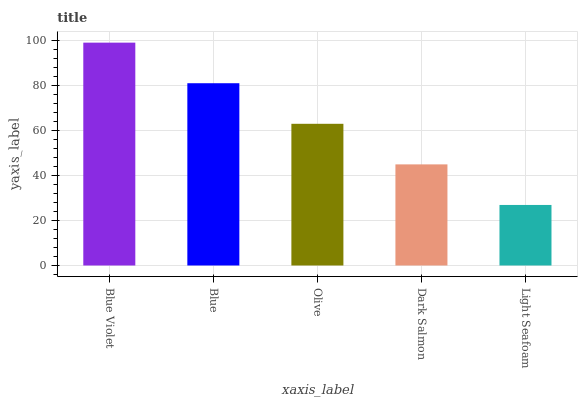Is Light Seafoam the minimum?
Answer yes or no. Yes. Is Blue Violet the maximum?
Answer yes or no. Yes. Is Blue the minimum?
Answer yes or no. No. Is Blue the maximum?
Answer yes or no. No. Is Blue Violet greater than Blue?
Answer yes or no. Yes. Is Blue less than Blue Violet?
Answer yes or no. Yes. Is Blue greater than Blue Violet?
Answer yes or no. No. Is Blue Violet less than Blue?
Answer yes or no. No. Is Olive the high median?
Answer yes or no. Yes. Is Olive the low median?
Answer yes or no. Yes. Is Dark Salmon the high median?
Answer yes or no. No. Is Blue the low median?
Answer yes or no. No. 